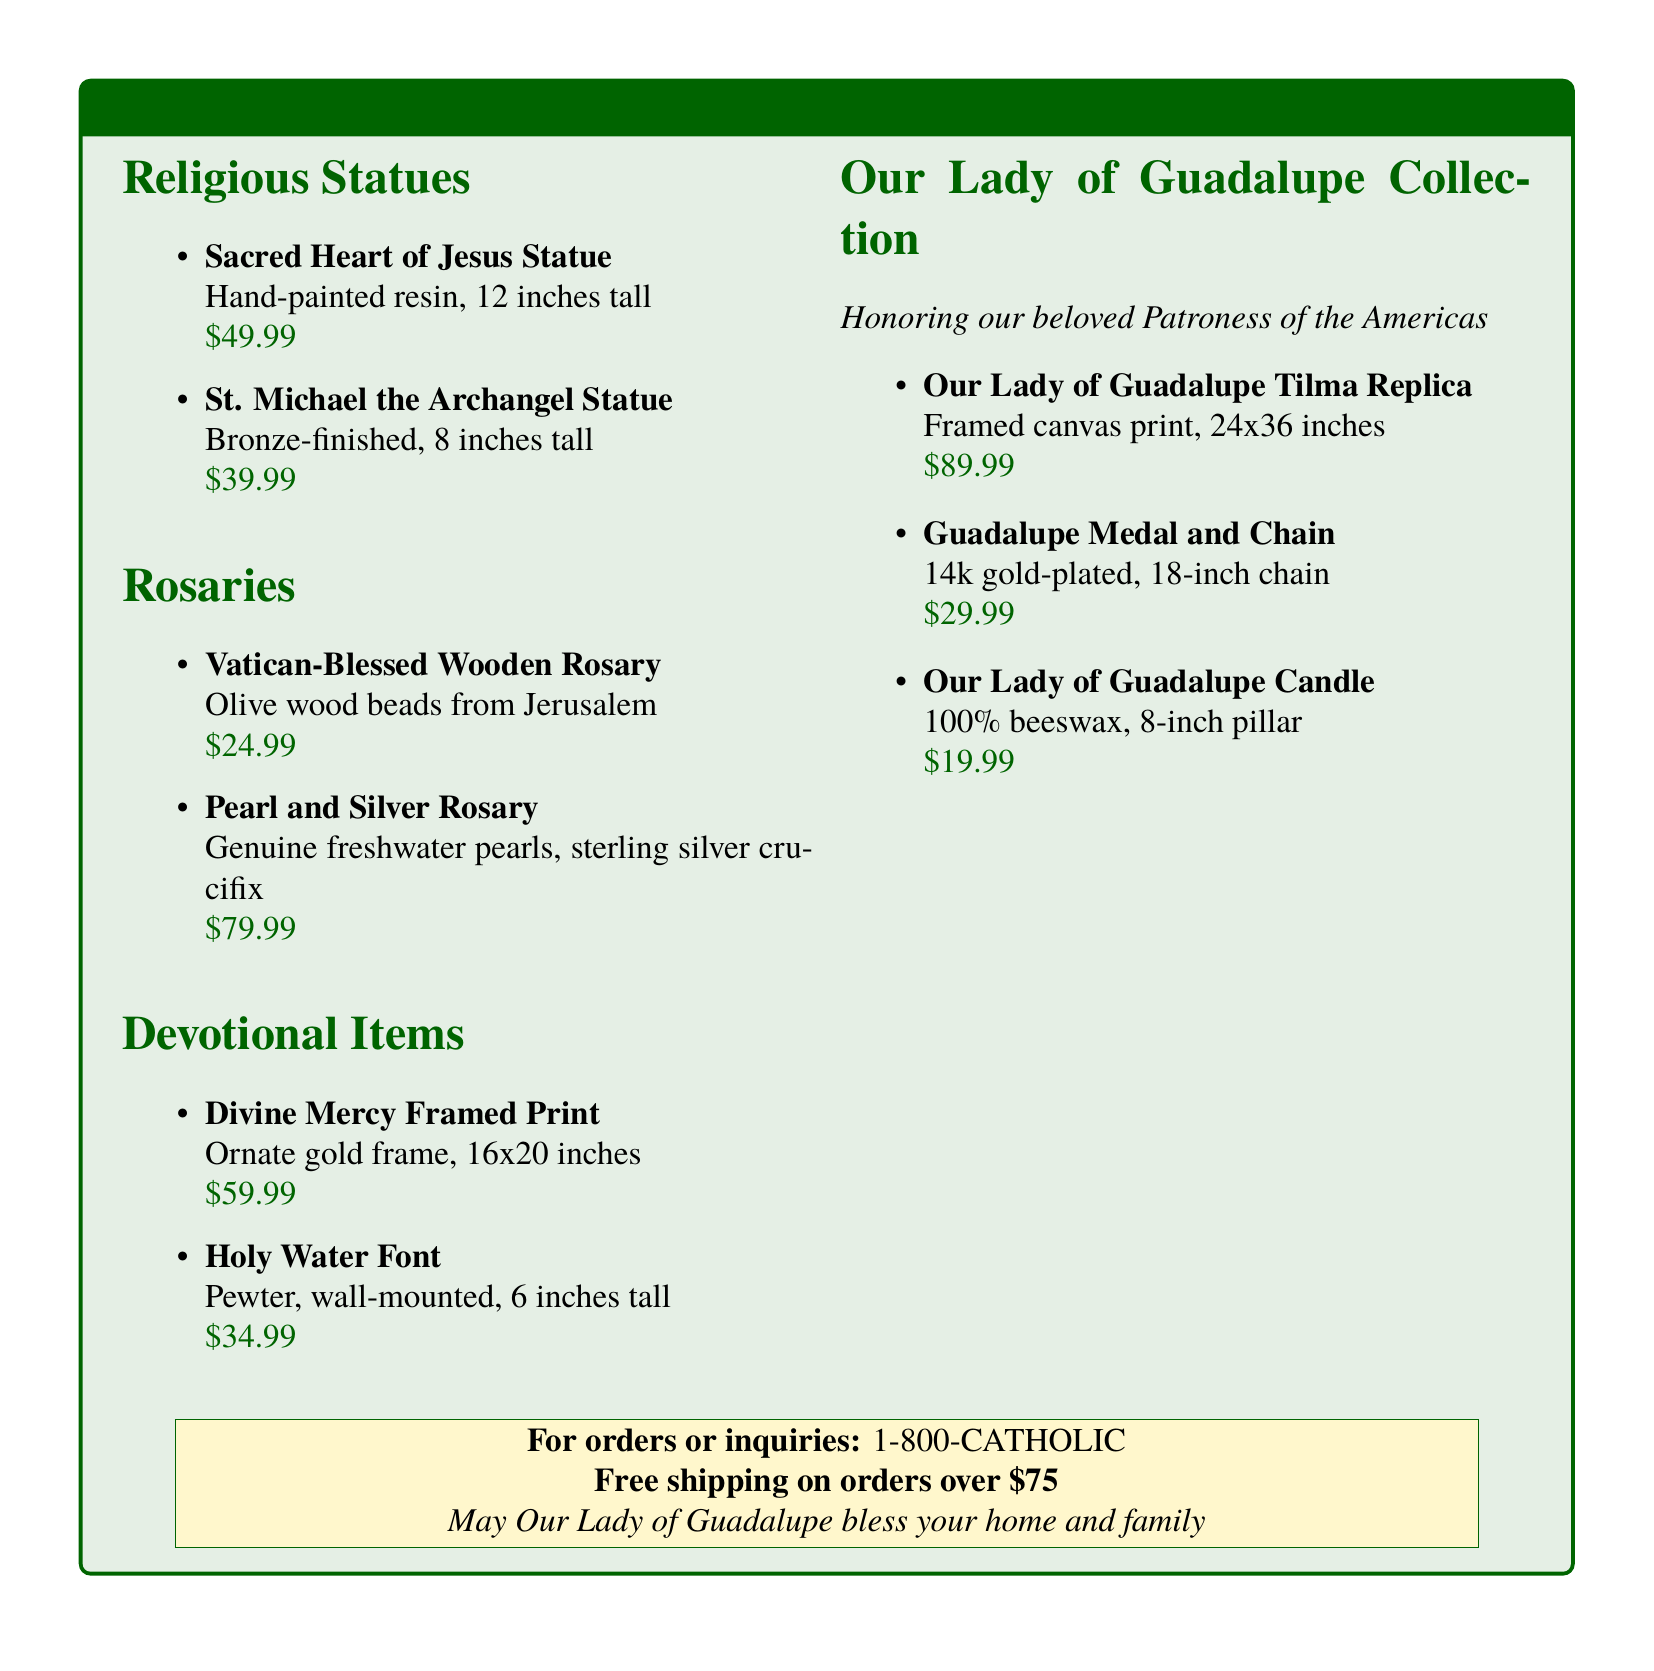What is the price of the Sacred Heart of Jesus Statue? The price is listed next to the item in the document.
Answer: $49.99 How tall is the St. Michael the Archangel Statue? The height of the statue is provided in the document.
Answer: 8 inches What type of wood is used for the Vatican-Blessed Wooden Rosary? The document specifies the material used for the beads.
Answer: Olive wood What is the size of the Our Lady of Guadalupe Tilma Replica? The document includes dimensions for the replica.
Answer: 24x36 inches How much does the Pearl and Silver Rosary cost? The document lists the price for each item.
Answer: $79.99 What does the Our Lady of Guadalupe section honor? This information is summarized in the section's description.
Answer: Patroness of the Americas How many inches tall is the Holy Water Font? The height of this item is mentioned in the catalog.
Answer: 6 inches What medal is included with the Guadalupe Medal and Chain? The document specifies which medal is included.
Answer: Guadalupe Medal What is the material of the Our Lady of Guadalupe Candle? The document describes the composition of the candle.
Answer: 100% beeswax 